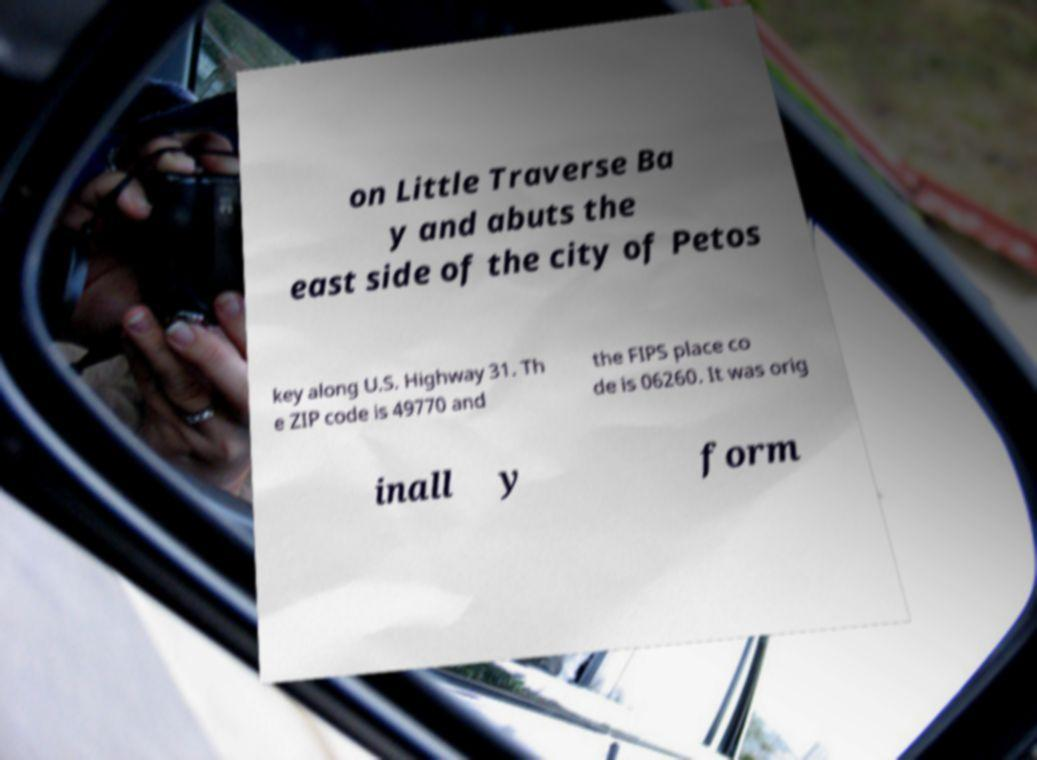There's text embedded in this image that I need extracted. Can you transcribe it verbatim? on Little Traverse Ba y and abuts the east side of the city of Petos key along U.S. Highway 31. Th e ZIP code is 49770 and the FIPS place co de is 06260. It was orig inall y form 